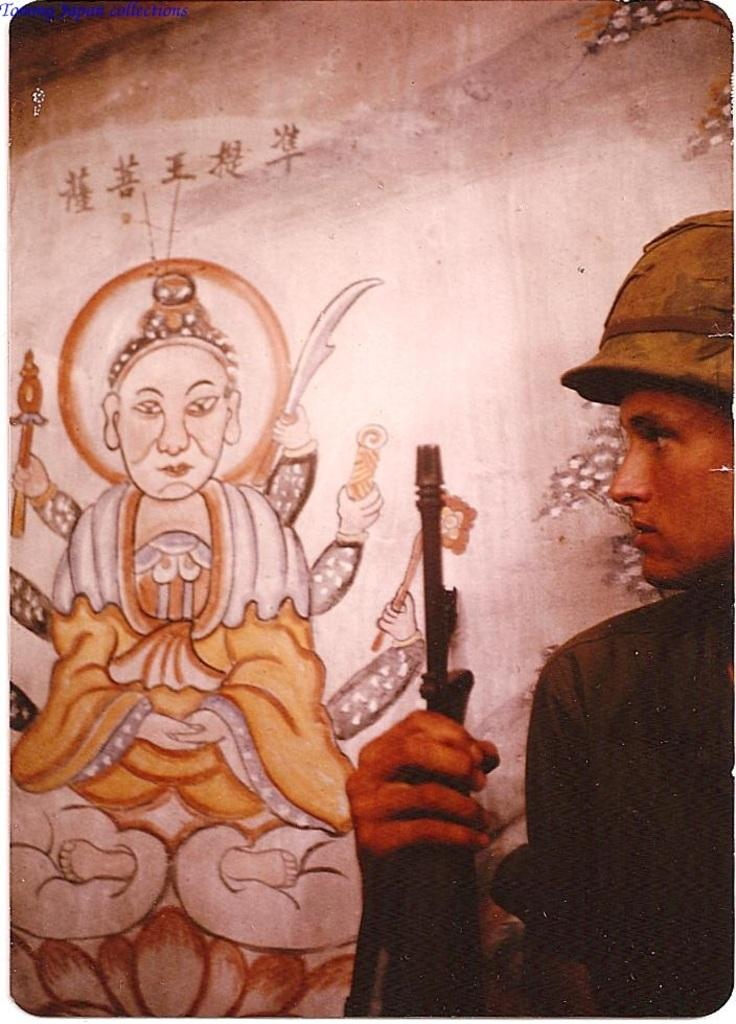What is the main subject of the image? There is a person in the image. What is the person holding in the image? The person is holding a gun. What can be seen in the background of the image? There is a painting on the wall in the background of the image. What type of wire is being used to hold the painting on the wall in the image? There is no wire visible in the image, and the painting is not mentioned as being held by any wire. 